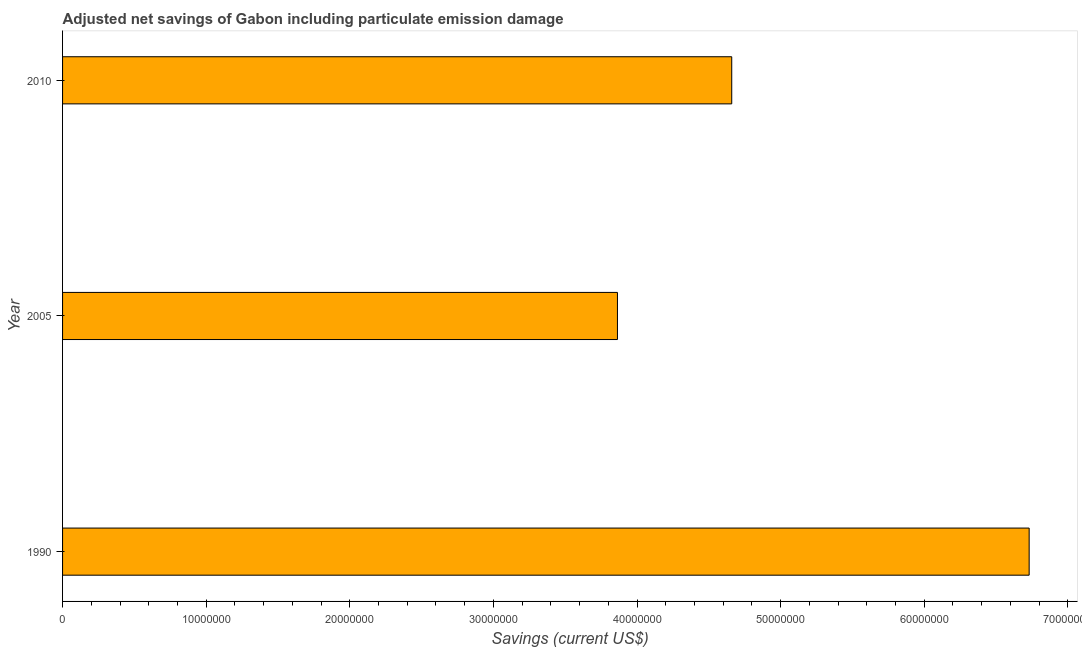Does the graph contain grids?
Ensure brevity in your answer.  No. What is the title of the graph?
Make the answer very short. Adjusted net savings of Gabon including particulate emission damage. What is the label or title of the X-axis?
Offer a very short reply. Savings (current US$). What is the adjusted net savings in 1990?
Keep it short and to the point. 6.73e+07. Across all years, what is the maximum adjusted net savings?
Provide a short and direct response. 6.73e+07. Across all years, what is the minimum adjusted net savings?
Your answer should be very brief. 3.86e+07. In which year was the adjusted net savings minimum?
Offer a very short reply. 2005. What is the sum of the adjusted net savings?
Your response must be concise. 1.53e+08. What is the difference between the adjusted net savings in 1990 and 2010?
Provide a succinct answer. 2.07e+07. What is the average adjusted net savings per year?
Ensure brevity in your answer.  5.08e+07. What is the median adjusted net savings?
Give a very brief answer. 4.66e+07. In how many years, is the adjusted net savings greater than 34000000 US$?
Give a very brief answer. 3. Do a majority of the years between 2010 and 2005 (inclusive) have adjusted net savings greater than 66000000 US$?
Keep it short and to the point. No. What is the ratio of the adjusted net savings in 2005 to that in 2010?
Your response must be concise. 0.83. Is the difference between the adjusted net savings in 1990 and 2005 greater than the difference between any two years?
Offer a terse response. Yes. What is the difference between the highest and the second highest adjusted net savings?
Offer a very short reply. 2.07e+07. Is the sum of the adjusted net savings in 1990 and 2010 greater than the maximum adjusted net savings across all years?
Provide a short and direct response. Yes. What is the difference between the highest and the lowest adjusted net savings?
Your answer should be compact. 2.87e+07. In how many years, is the adjusted net savings greater than the average adjusted net savings taken over all years?
Your answer should be very brief. 1. How many bars are there?
Keep it short and to the point. 3. How many years are there in the graph?
Ensure brevity in your answer.  3. What is the Savings (current US$) in 1990?
Your response must be concise. 6.73e+07. What is the Savings (current US$) in 2005?
Provide a short and direct response. 3.86e+07. What is the Savings (current US$) of 2010?
Provide a succinct answer. 4.66e+07. What is the difference between the Savings (current US$) in 1990 and 2005?
Your answer should be very brief. 2.87e+07. What is the difference between the Savings (current US$) in 1990 and 2010?
Offer a very short reply. 2.07e+07. What is the difference between the Savings (current US$) in 2005 and 2010?
Offer a very short reply. -7.96e+06. What is the ratio of the Savings (current US$) in 1990 to that in 2005?
Your answer should be compact. 1.74. What is the ratio of the Savings (current US$) in 1990 to that in 2010?
Offer a terse response. 1.44. What is the ratio of the Savings (current US$) in 2005 to that in 2010?
Your response must be concise. 0.83. 